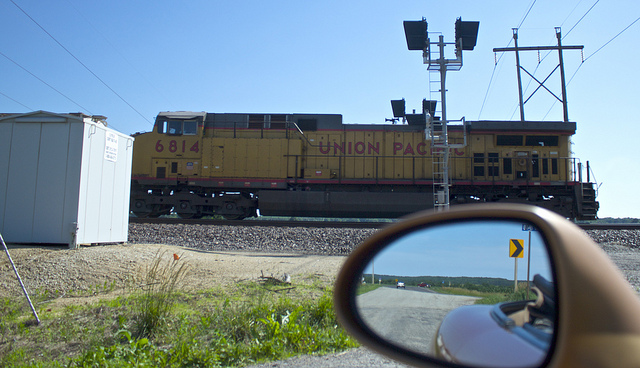Please transcribe the text in this image. UNION PAC 6814 